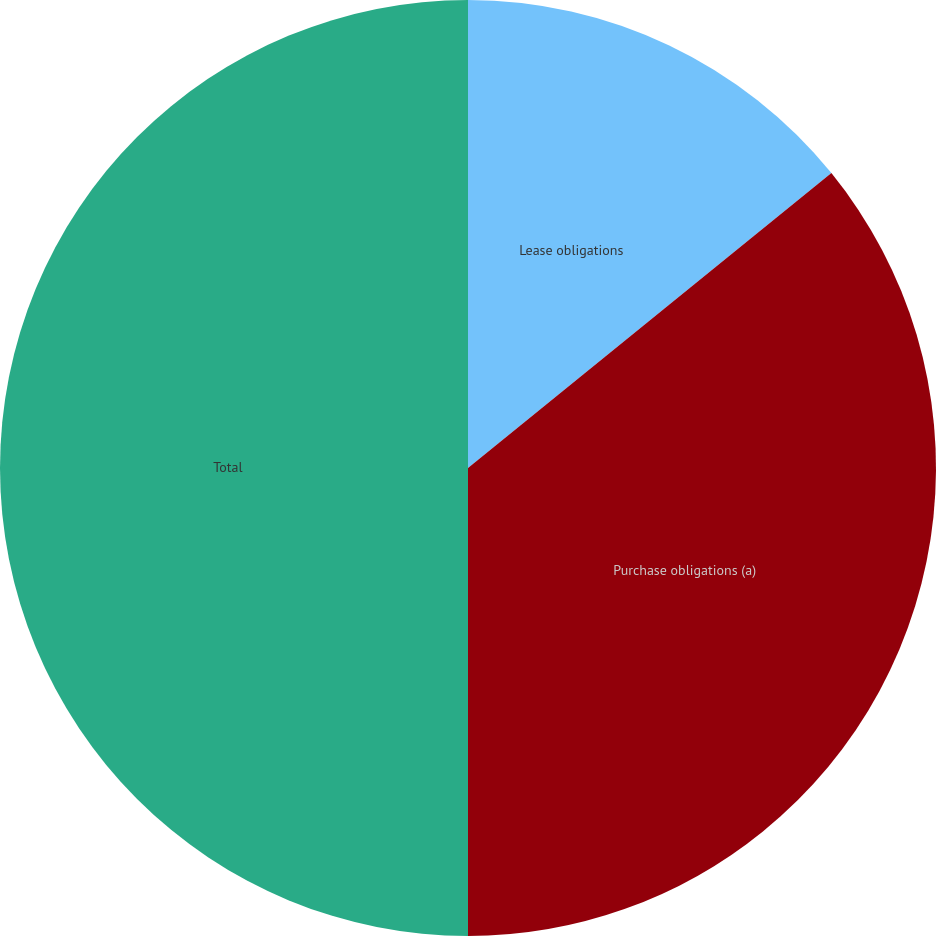Convert chart to OTSL. <chart><loc_0><loc_0><loc_500><loc_500><pie_chart><fcel>Lease obligations<fcel>Purchase obligations (a)<fcel>Total<nl><fcel>14.15%<fcel>35.85%<fcel>50.0%<nl></chart> 